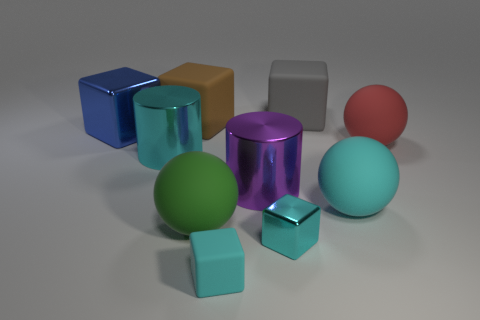There is a big matte block that is in front of the cube that is behind the big brown object; what is its color?
Provide a short and direct response. Brown. Is the shape of the green rubber thing the same as the big cyan thing that is to the right of the brown cube?
Keep it short and to the point. Yes. There is a object that is in front of the cyan metal cube in front of the cylinder to the left of the green rubber thing; what is it made of?
Give a very brief answer. Rubber. Is there another red sphere of the same size as the red sphere?
Your answer should be compact. No. There is a red object that is the same material as the big green thing; what size is it?
Offer a terse response. Large. What shape is the green thing?
Provide a succinct answer. Sphere. Does the red object have the same material as the big blue thing to the left of the big gray thing?
Your response must be concise. No. What number of things are either small yellow shiny blocks or brown blocks?
Give a very brief answer. 1. Is there a large purple thing?
Your answer should be compact. Yes. The large object behind the large rubber block left of the big gray cube is what shape?
Your response must be concise. Cube. 